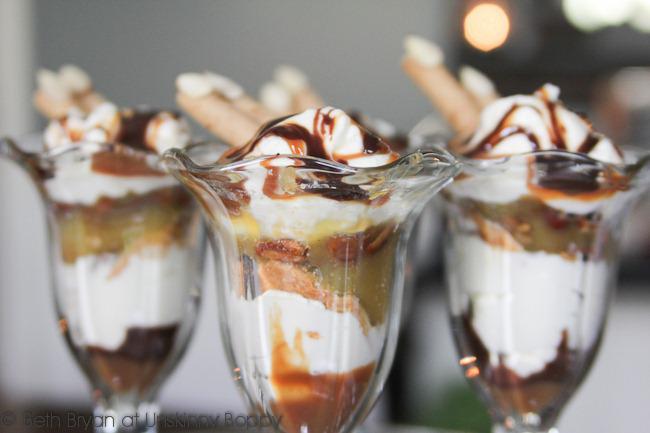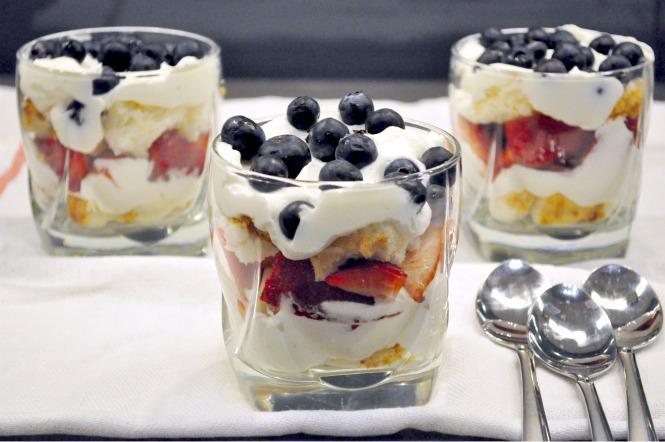The first image is the image on the left, the second image is the image on the right. Given the left and right images, does the statement "The left photo contains two cups full of dessert." hold true? Answer yes or no. No. The first image is the image on the left, the second image is the image on the right. Given the left and right images, does the statement "One of the images shows exactly one dessert container." hold true? Answer yes or no. No. 